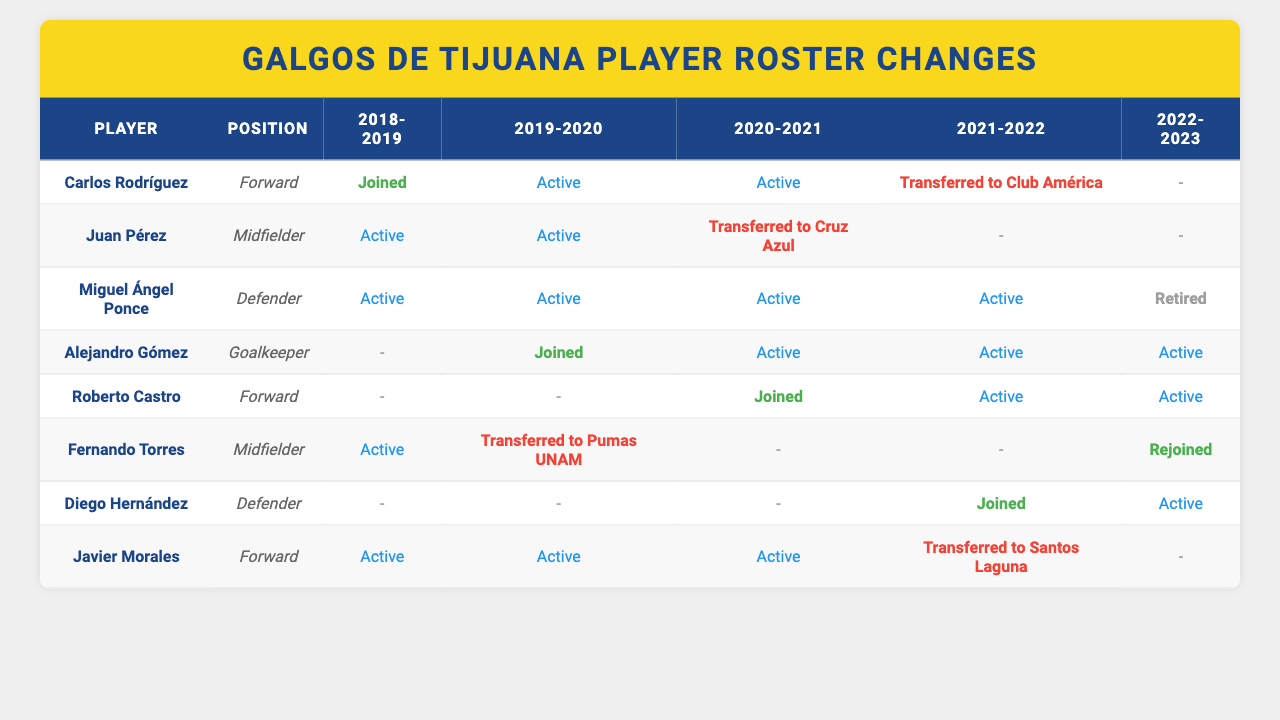What is the status of Carlos Rodríguez in the 2021-2022 season? In the table, it shows that Carlos Rodríguez was "Transferred to Club América" in the 2021-2022 season.
Answer: Transferred to Club América How many seasons did Miguel Ángel Ponce remain active as a player? The table indicates that Miguel Ángel Ponce was active in the seasons 2018-2019, 2019-2020, 2020-2021, and 2021-2022. This totals to 4 seasons active.
Answer: 4 Which player was active throughout the 2020-2021 season? According to the table, several players were active in the 2020-2021 season, including Miguel Ángel Ponce, Alejandro Gómez, and Roberto Castro.
Answer: Miguel Ángel Ponce, Alejandro Gómez, Roberto Castro Did Fernando Torres ever retire during the recorded seasons? By examining the table, Fernando Torres was never listed as retired in any season; rather, he was transferred and then rejoined in the 2022-2023 season.
Answer: No Which player joined the team in the 2019-2020 season and remained active afterward? The table shows that Alejandro Gómez joined in the 2019-2020 season and was active in the following seasons, including 2020-2021, 2021-2022, and 2022-2023.
Answer: Alejandro Gómez What percentage of players in the table had transferred to another team by the end of the 2022-2023 season? According to the table, there are 8 players listed. Out of them, 4 players transferred to another team (Carlos Rodríguez, Juan Pérez, Fernando Torres, and Javier Morales). The percentage of transferred players is (4/8) * 100 = 50%.
Answer: 50% Which position had the highest number of active players in the 2022-2023 season? By checking the table, we see that in the 2022-2023 season, there are 2 active forwards (Roberto Castro) and 3 active midfielders (Fernando Torres and Juan Pérez) alongside 1 active defender (Diego Hernández) and 1 active goalkeeper (Alejandro Gómez). Thus, midfielders had the highest number of active players.
Answer: Midfielders In the 2020-2021 season, which player joined the team and what position did he play? The table states that Roberto Castro joined the team in the 2020-2021 season as a Forward.
Answer: Roberto Castro, Forward How many players have transferred to another team in total from 2018 to 2023? By examining the table, the players who have transferred are Carlos Rodríguez (to Club América), Juan Pérez (to Cruz Azul), Fernando Torres (to Pumas UNAM), and Javier Morales (to Santos Laguna). Thus, 4 players have transferred.
Answer: 4 Was there any player that joined the team but never was marked as active? In the table, the players who joined but were never marked as active are Carlos Rodríguez (joined in 2018-2019) and Diego Hernández (joined in 2021-2022). Since data indicates they played in different seasons, the assertion is true. Therefore, the statement is confirmed as true.
Answer: Yes 